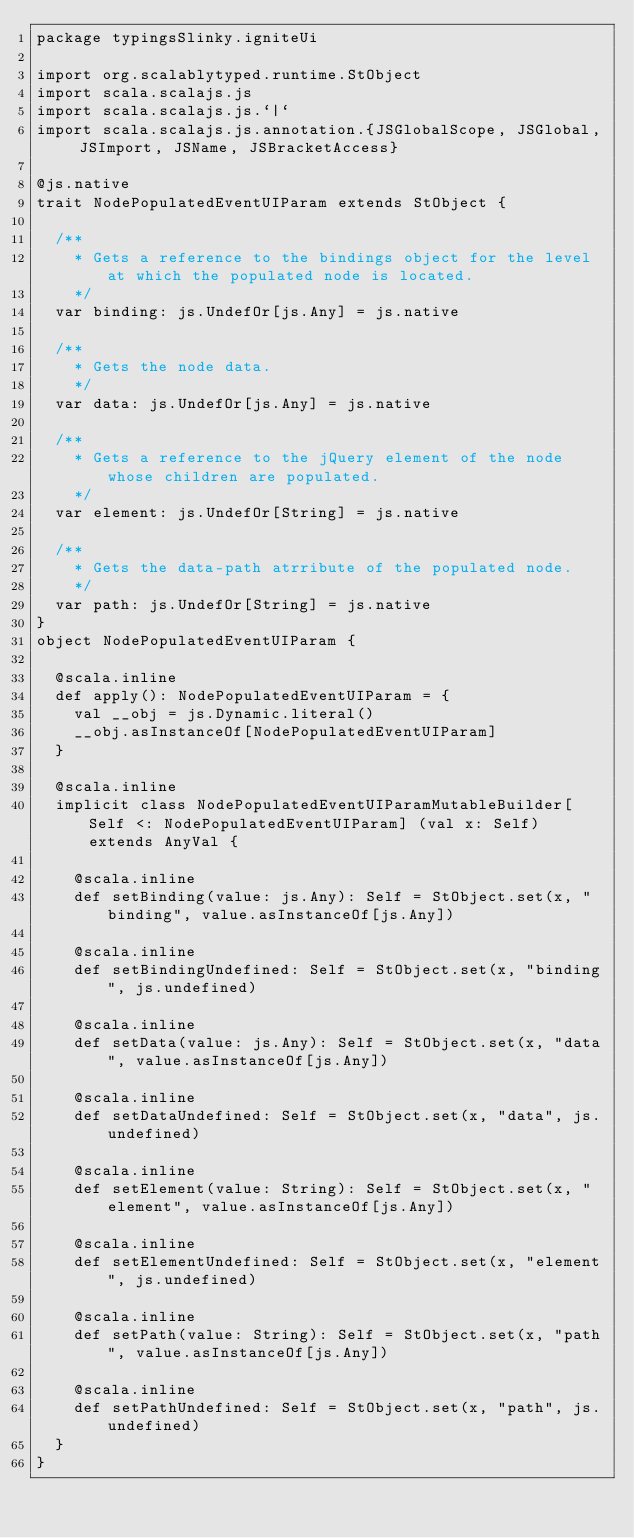<code> <loc_0><loc_0><loc_500><loc_500><_Scala_>package typingsSlinky.igniteUi

import org.scalablytyped.runtime.StObject
import scala.scalajs.js
import scala.scalajs.js.`|`
import scala.scalajs.js.annotation.{JSGlobalScope, JSGlobal, JSImport, JSName, JSBracketAccess}

@js.native
trait NodePopulatedEventUIParam extends StObject {
  
  /**
    * Gets a reference to the bindings object for the level at which the populated node is located.
    */
  var binding: js.UndefOr[js.Any] = js.native
  
  /**
    * Gets the node data.
    */
  var data: js.UndefOr[js.Any] = js.native
  
  /**
    * Gets a reference to the jQuery element of the node whose children are populated.
    */
  var element: js.UndefOr[String] = js.native
  
  /**
    * Gets the data-path atrribute of the populated node.
    */
  var path: js.UndefOr[String] = js.native
}
object NodePopulatedEventUIParam {
  
  @scala.inline
  def apply(): NodePopulatedEventUIParam = {
    val __obj = js.Dynamic.literal()
    __obj.asInstanceOf[NodePopulatedEventUIParam]
  }
  
  @scala.inline
  implicit class NodePopulatedEventUIParamMutableBuilder[Self <: NodePopulatedEventUIParam] (val x: Self) extends AnyVal {
    
    @scala.inline
    def setBinding(value: js.Any): Self = StObject.set(x, "binding", value.asInstanceOf[js.Any])
    
    @scala.inline
    def setBindingUndefined: Self = StObject.set(x, "binding", js.undefined)
    
    @scala.inline
    def setData(value: js.Any): Self = StObject.set(x, "data", value.asInstanceOf[js.Any])
    
    @scala.inline
    def setDataUndefined: Self = StObject.set(x, "data", js.undefined)
    
    @scala.inline
    def setElement(value: String): Self = StObject.set(x, "element", value.asInstanceOf[js.Any])
    
    @scala.inline
    def setElementUndefined: Self = StObject.set(x, "element", js.undefined)
    
    @scala.inline
    def setPath(value: String): Self = StObject.set(x, "path", value.asInstanceOf[js.Any])
    
    @scala.inline
    def setPathUndefined: Self = StObject.set(x, "path", js.undefined)
  }
}
</code> 